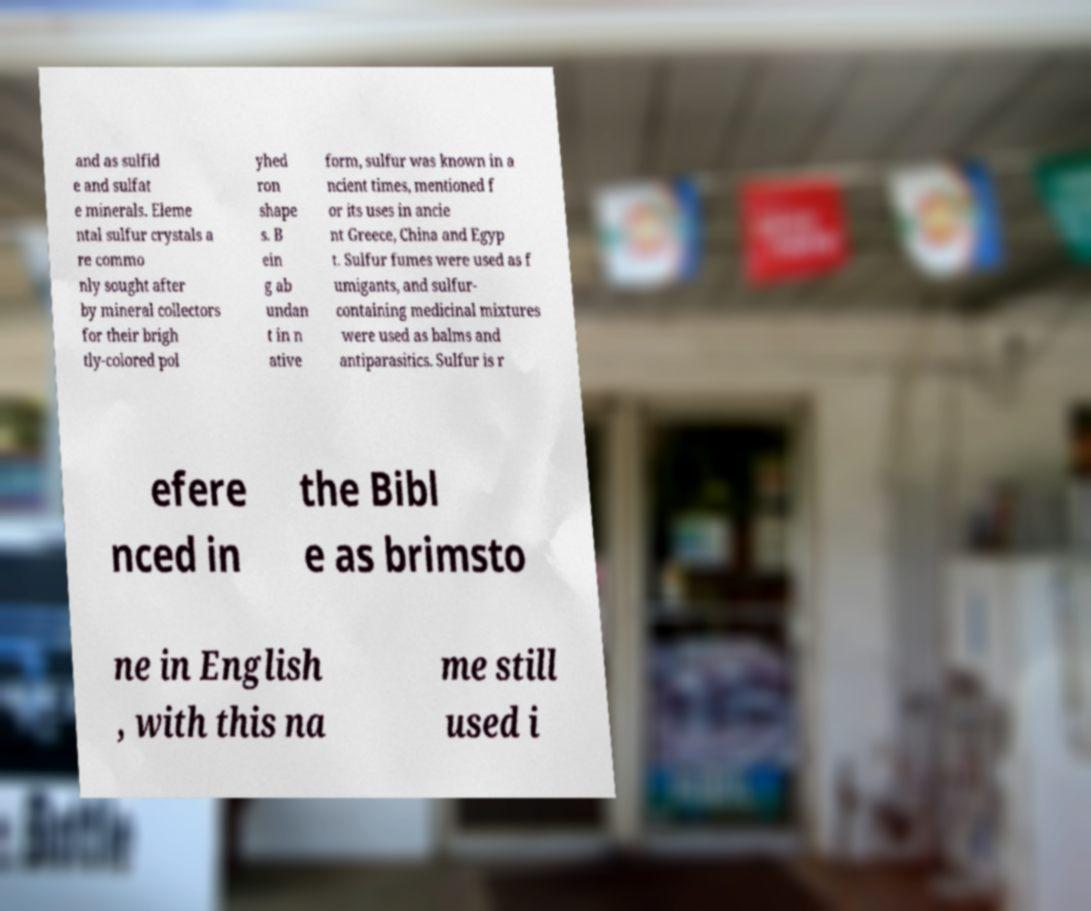Can you read and provide the text displayed in the image?This photo seems to have some interesting text. Can you extract and type it out for me? and as sulfid e and sulfat e minerals. Eleme ntal sulfur crystals a re commo nly sought after by mineral collectors for their brigh tly-colored pol yhed ron shape s. B ein g ab undan t in n ative form, sulfur was known in a ncient times, mentioned f or its uses in ancie nt Greece, China and Egyp t. Sulfur fumes were used as f umigants, and sulfur- containing medicinal mixtures were used as balms and antiparasitics. Sulfur is r efere nced in the Bibl e as brimsto ne in English , with this na me still used i 